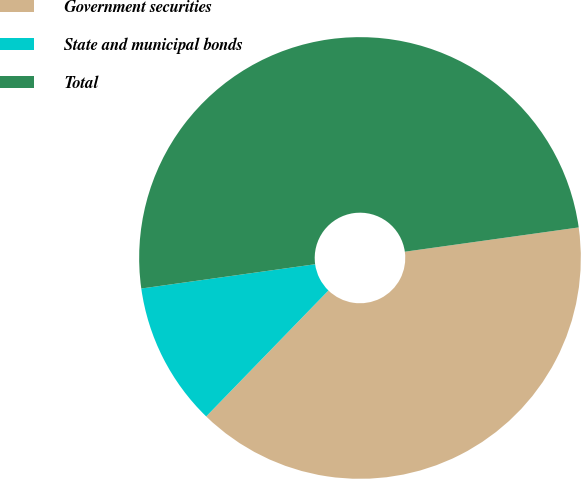Convert chart to OTSL. <chart><loc_0><loc_0><loc_500><loc_500><pie_chart><fcel>Government securities<fcel>State and municipal bonds<fcel>Total<nl><fcel>39.47%<fcel>10.53%<fcel>50.0%<nl></chart> 